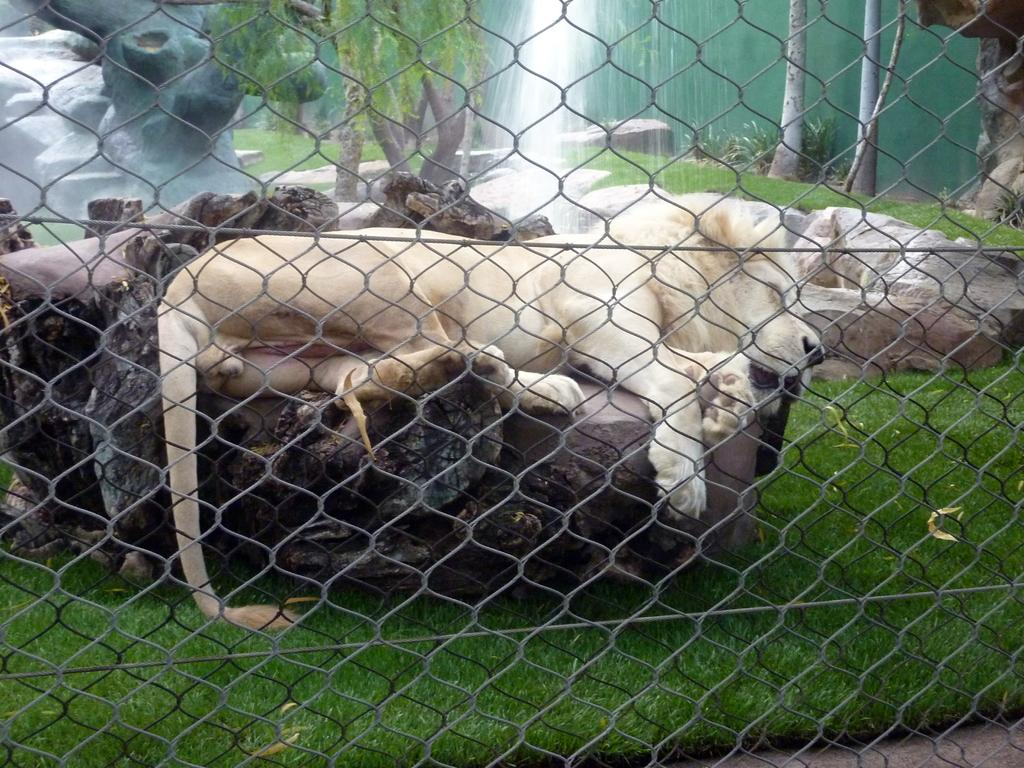What animal can be seen in the image? There is a lion lying on a rock in the image. What type of terrain is visible in the image? There is grass on the ground in the image. What type of barrier is present in the image? There is mesh fencing in the image. What can be seen in the background of the image? There are trees in the background of the image. What feature is present in the image that might provide water? There is a fountain in the image. Can you see the lion wearing a crown in the image? No, the lion is not wearing a crown in the image. Is there a birthday celebration happening in the image? There is no indication of a birthday celebration in the image. 